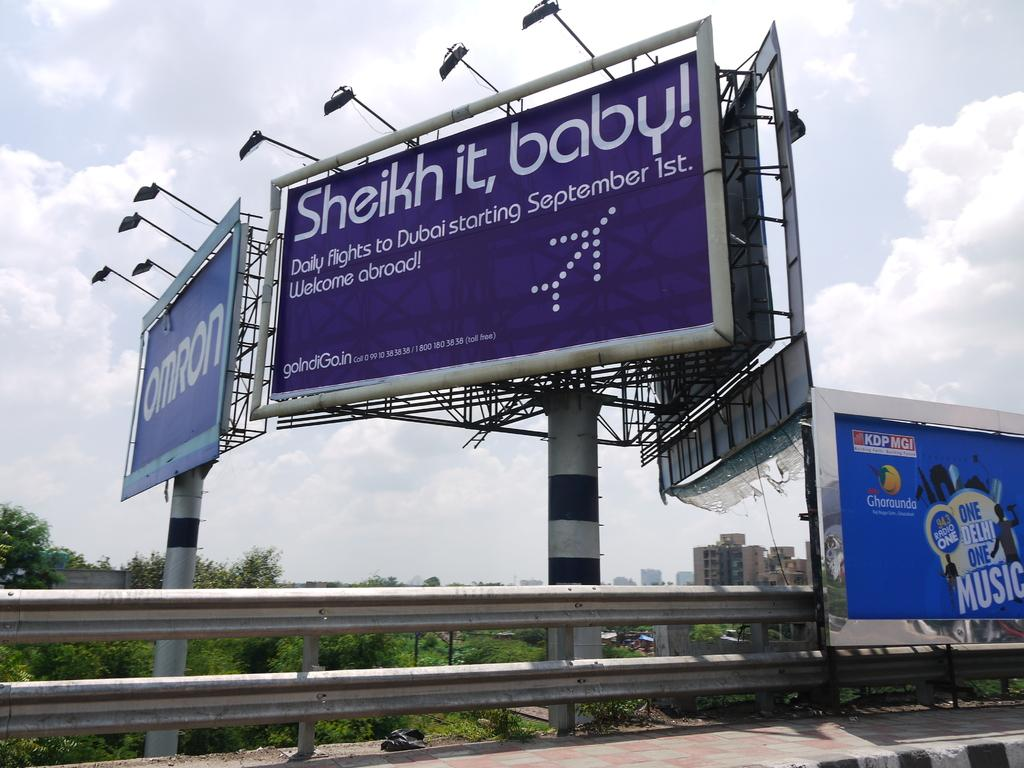<image>
Create a compact narrative representing the image presented. Billboards along the highway in India with one from a Radio Station and another one from an Airline 